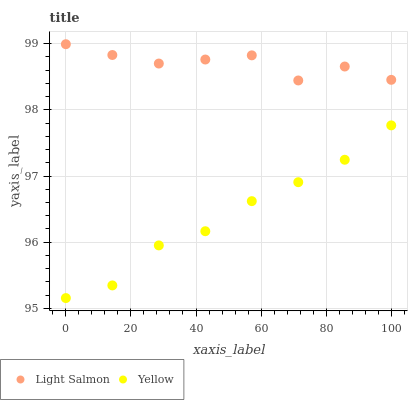Does Yellow have the minimum area under the curve?
Answer yes or no. Yes. Does Light Salmon have the maximum area under the curve?
Answer yes or no. Yes. Does Yellow have the maximum area under the curve?
Answer yes or no. No. Is Yellow the smoothest?
Answer yes or no. Yes. Is Light Salmon the roughest?
Answer yes or no. Yes. Is Yellow the roughest?
Answer yes or no. No. Does Yellow have the lowest value?
Answer yes or no. Yes. Does Light Salmon have the highest value?
Answer yes or no. Yes. Does Yellow have the highest value?
Answer yes or no. No. Is Yellow less than Light Salmon?
Answer yes or no. Yes. Is Light Salmon greater than Yellow?
Answer yes or no. Yes. Does Yellow intersect Light Salmon?
Answer yes or no. No. 